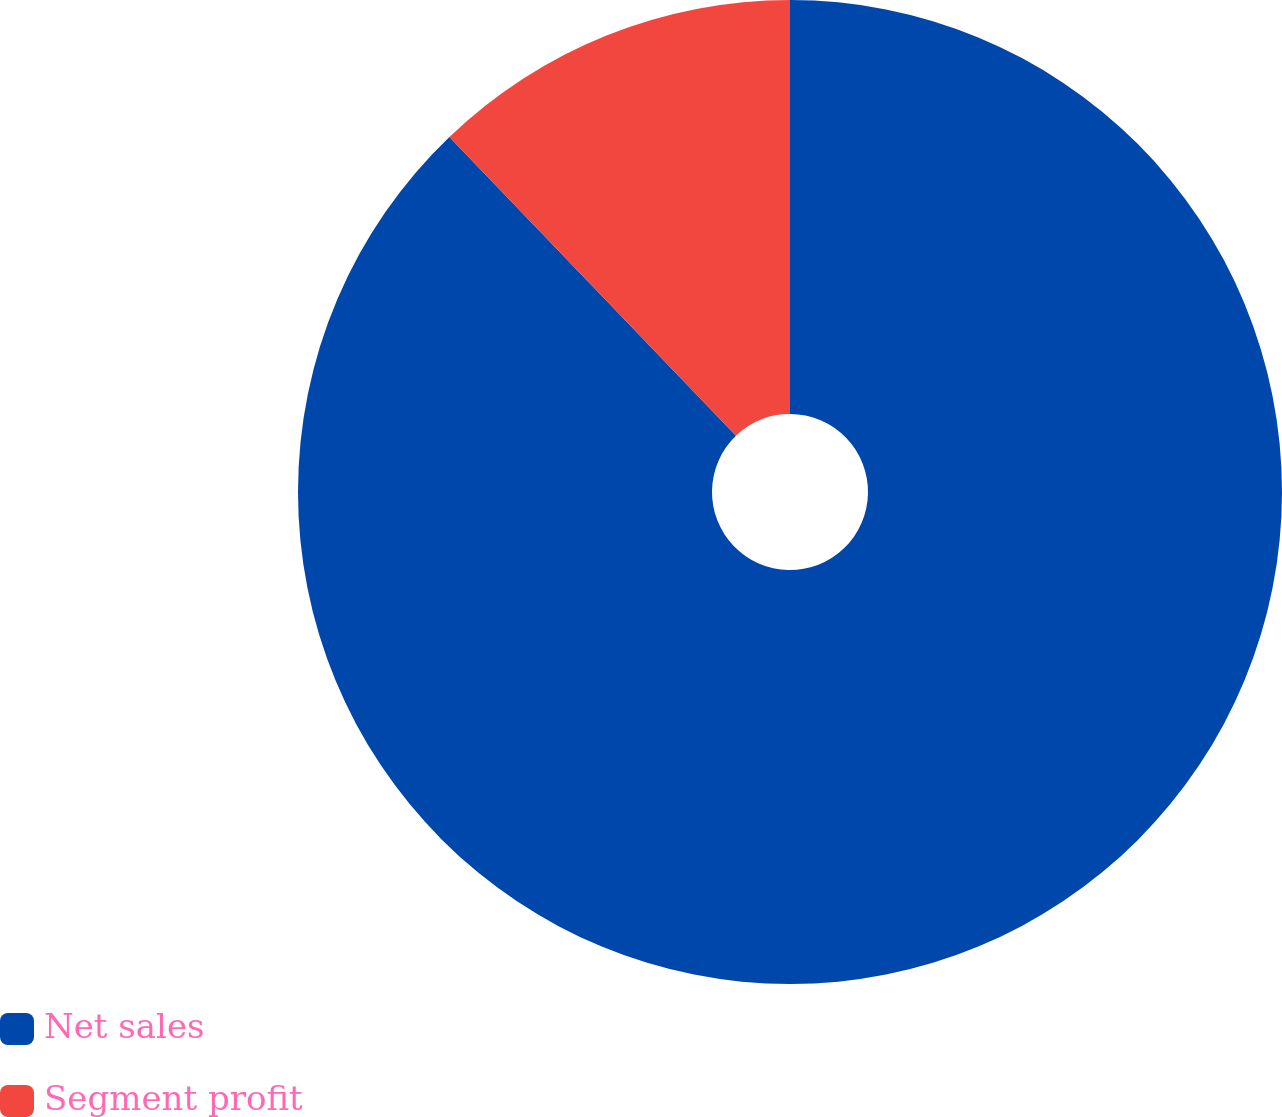Convert chart. <chart><loc_0><loc_0><loc_500><loc_500><pie_chart><fcel>Net sales<fcel>Segment profit<nl><fcel>87.83%<fcel>12.17%<nl></chart> 